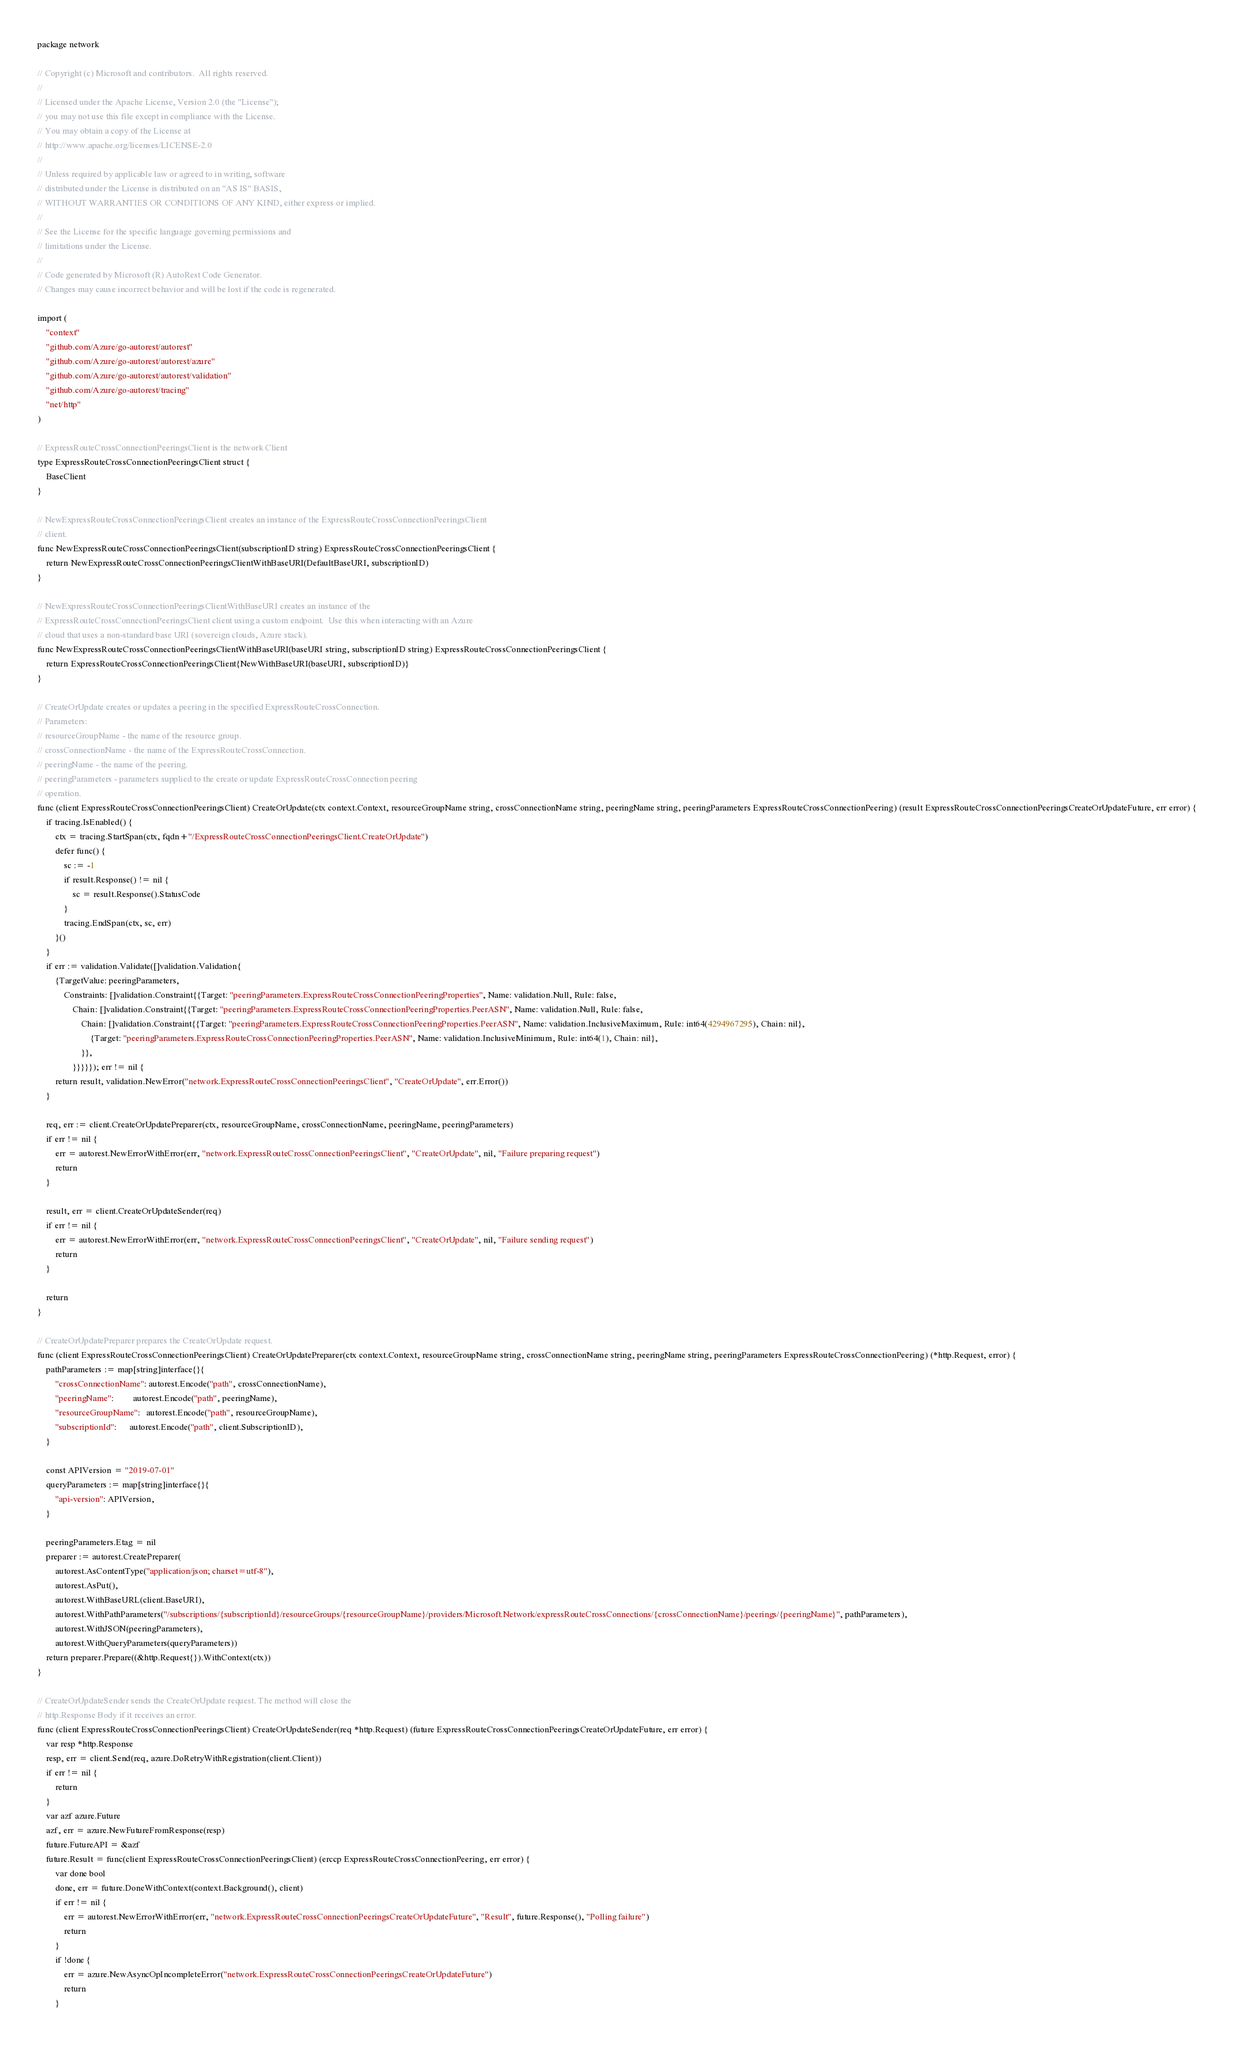<code> <loc_0><loc_0><loc_500><loc_500><_Go_>package network

// Copyright (c) Microsoft and contributors.  All rights reserved.
//
// Licensed under the Apache License, Version 2.0 (the "License");
// you may not use this file except in compliance with the License.
// You may obtain a copy of the License at
// http://www.apache.org/licenses/LICENSE-2.0
//
// Unless required by applicable law or agreed to in writing, software
// distributed under the License is distributed on an "AS IS" BASIS,
// WITHOUT WARRANTIES OR CONDITIONS OF ANY KIND, either express or implied.
//
// See the License for the specific language governing permissions and
// limitations under the License.
//
// Code generated by Microsoft (R) AutoRest Code Generator.
// Changes may cause incorrect behavior and will be lost if the code is regenerated.

import (
	"context"
	"github.com/Azure/go-autorest/autorest"
	"github.com/Azure/go-autorest/autorest/azure"
	"github.com/Azure/go-autorest/autorest/validation"
	"github.com/Azure/go-autorest/tracing"
	"net/http"
)

// ExpressRouteCrossConnectionPeeringsClient is the network Client
type ExpressRouteCrossConnectionPeeringsClient struct {
	BaseClient
}

// NewExpressRouteCrossConnectionPeeringsClient creates an instance of the ExpressRouteCrossConnectionPeeringsClient
// client.
func NewExpressRouteCrossConnectionPeeringsClient(subscriptionID string) ExpressRouteCrossConnectionPeeringsClient {
	return NewExpressRouteCrossConnectionPeeringsClientWithBaseURI(DefaultBaseURI, subscriptionID)
}

// NewExpressRouteCrossConnectionPeeringsClientWithBaseURI creates an instance of the
// ExpressRouteCrossConnectionPeeringsClient client using a custom endpoint.  Use this when interacting with an Azure
// cloud that uses a non-standard base URI (sovereign clouds, Azure stack).
func NewExpressRouteCrossConnectionPeeringsClientWithBaseURI(baseURI string, subscriptionID string) ExpressRouteCrossConnectionPeeringsClient {
	return ExpressRouteCrossConnectionPeeringsClient{NewWithBaseURI(baseURI, subscriptionID)}
}

// CreateOrUpdate creates or updates a peering in the specified ExpressRouteCrossConnection.
// Parameters:
// resourceGroupName - the name of the resource group.
// crossConnectionName - the name of the ExpressRouteCrossConnection.
// peeringName - the name of the peering.
// peeringParameters - parameters supplied to the create or update ExpressRouteCrossConnection peering
// operation.
func (client ExpressRouteCrossConnectionPeeringsClient) CreateOrUpdate(ctx context.Context, resourceGroupName string, crossConnectionName string, peeringName string, peeringParameters ExpressRouteCrossConnectionPeering) (result ExpressRouteCrossConnectionPeeringsCreateOrUpdateFuture, err error) {
	if tracing.IsEnabled() {
		ctx = tracing.StartSpan(ctx, fqdn+"/ExpressRouteCrossConnectionPeeringsClient.CreateOrUpdate")
		defer func() {
			sc := -1
			if result.Response() != nil {
				sc = result.Response().StatusCode
			}
			tracing.EndSpan(ctx, sc, err)
		}()
	}
	if err := validation.Validate([]validation.Validation{
		{TargetValue: peeringParameters,
			Constraints: []validation.Constraint{{Target: "peeringParameters.ExpressRouteCrossConnectionPeeringProperties", Name: validation.Null, Rule: false,
				Chain: []validation.Constraint{{Target: "peeringParameters.ExpressRouteCrossConnectionPeeringProperties.PeerASN", Name: validation.Null, Rule: false,
					Chain: []validation.Constraint{{Target: "peeringParameters.ExpressRouteCrossConnectionPeeringProperties.PeerASN", Name: validation.InclusiveMaximum, Rule: int64(4294967295), Chain: nil},
						{Target: "peeringParameters.ExpressRouteCrossConnectionPeeringProperties.PeerASN", Name: validation.InclusiveMinimum, Rule: int64(1), Chain: nil},
					}},
				}}}}}); err != nil {
		return result, validation.NewError("network.ExpressRouteCrossConnectionPeeringsClient", "CreateOrUpdate", err.Error())
	}

	req, err := client.CreateOrUpdatePreparer(ctx, resourceGroupName, crossConnectionName, peeringName, peeringParameters)
	if err != nil {
		err = autorest.NewErrorWithError(err, "network.ExpressRouteCrossConnectionPeeringsClient", "CreateOrUpdate", nil, "Failure preparing request")
		return
	}

	result, err = client.CreateOrUpdateSender(req)
	if err != nil {
		err = autorest.NewErrorWithError(err, "network.ExpressRouteCrossConnectionPeeringsClient", "CreateOrUpdate", nil, "Failure sending request")
		return
	}

	return
}

// CreateOrUpdatePreparer prepares the CreateOrUpdate request.
func (client ExpressRouteCrossConnectionPeeringsClient) CreateOrUpdatePreparer(ctx context.Context, resourceGroupName string, crossConnectionName string, peeringName string, peeringParameters ExpressRouteCrossConnectionPeering) (*http.Request, error) {
	pathParameters := map[string]interface{}{
		"crossConnectionName": autorest.Encode("path", crossConnectionName),
		"peeringName":         autorest.Encode("path", peeringName),
		"resourceGroupName":   autorest.Encode("path", resourceGroupName),
		"subscriptionId":      autorest.Encode("path", client.SubscriptionID),
	}

	const APIVersion = "2019-07-01"
	queryParameters := map[string]interface{}{
		"api-version": APIVersion,
	}

	peeringParameters.Etag = nil
	preparer := autorest.CreatePreparer(
		autorest.AsContentType("application/json; charset=utf-8"),
		autorest.AsPut(),
		autorest.WithBaseURL(client.BaseURI),
		autorest.WithPathParameters("/subscriptions/{subscriptionId}/resourceGroups/{resourceGroupName}/providers/Microsoft.Network/expressRouteCrossConnections/{crossConnectionName}/peerings/{peeringName}", pathParameters),
		autorest.WithJSON(peeringParameters),
		autorest.WithQueryParameters(queryParameters))
	return preparer.Prepare((&http.Request{}).WithContext(ctx))
}

// CreateOrUpdateSender sends the CreateOrUpdate request. The method will close the
// http.Response Body if it receives an error.
func (client ExpressRouteCrossConnectionPeeringsClient) CreateOrUpdateSender(req *http.Request) (future ExpressRouteCrossConnectionPeeringsCreateOrUpdateFuture, err error) {
	var resp *http.Response
	resp, err = client.Send(req, azure.DoRetryWithRegistration(client.Client))
	if err != nil {
		return
	}
	var azf azure.Future
	azf, err = azure.NewFutureFromResponse(resp)
	future.FutureAPI = &azf
	future.Result = func(client ExpressRouteCrossConnectionPeeringsClient) (erccp ExpressRouteCrossConnectionPeering, err error) {
		var done bool
		done, err = future.DoneWithContext(context.Background(), client)
		if err != nil {
			err = autorest.NewErrorWithError(err, "network.ExpressRouteCrossConnectionPeeringsCreateOrUpdateFuture", "Result", future.Response(), "Polling failure")
			return
		}
		if !done {
			err = azure.NewAsyncOpIncompleteError("network.ExpressRouteCrossConnectionPeeringsCreateOrUpdateFuture")
			return
		}</code> 